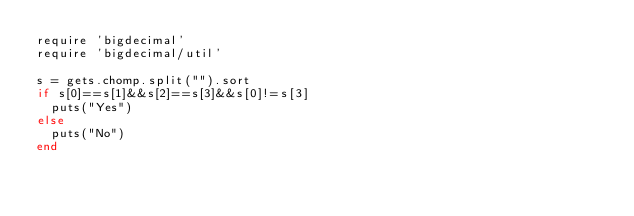Convert code to text. <code><loc_0><loc_0><loc_500><loc_500><_Ruby_>require 'bigdecimal'
require 'bigdecimal/util'

s = gets.chomp.split("").sort
if s[0]==s[1]&&s[2]==s[3]&&s[0]!=s[3]
  puts("Yes")
else
  puts("No")
end
</code> 